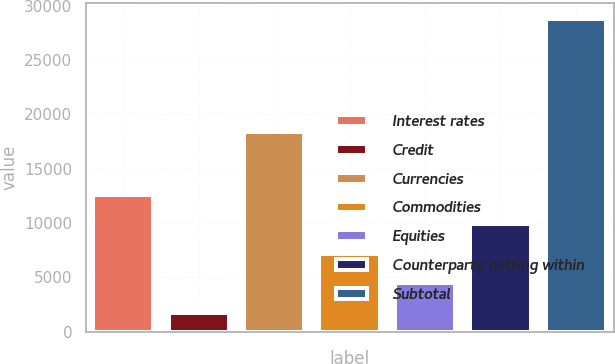Convert chart to OTSL. <chart><loc_0><loc_0><loc_500><loc_500><bar_chart><fcel>Interest rates<fcel>Credit<fcel>Currencies<fcel>Commodities<fcel>Equities<fcel>Counterparty netting within<fcel>Subtotal<nl><fcel>12587<fcel>1763<fcel>18344<fcel>7175<fcel>4469<fcel>9881<fcel>28823<nl></chart> 